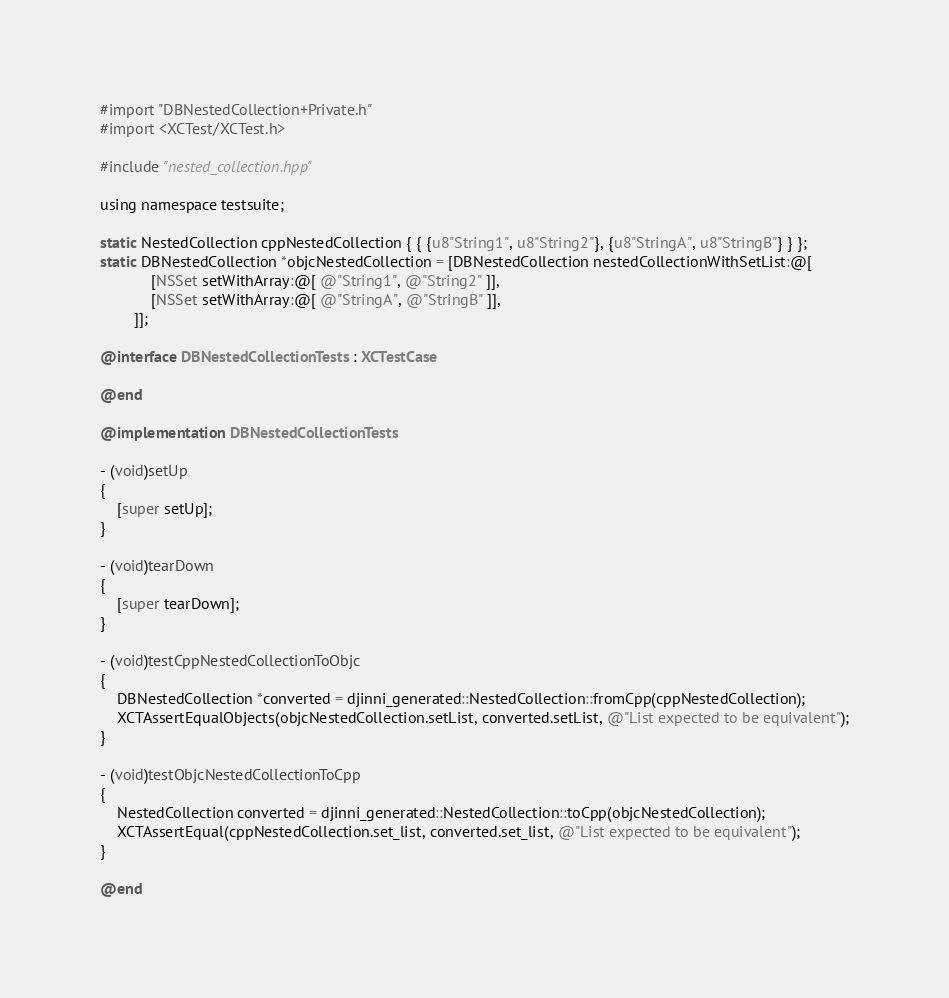<code> <loc_0><loc_0><loc_500><loc_500><_ObjectiveC_>#import "DBNestedCollection+Private.h"
#import <XCTest/XCTest.h>

#include "nested_collection.hpp"

using namespace testsuite;

static NestedCollection cppNestedCollection { { {u8"String1", u8"String2"}, {u8"StringA", u8"StringB"} } };
static DBNestedCollection *objcNestedCollection = [DBNestedCollection nestedCollectionWithSetList:@[
            [NSSet setWithArray:@[ @"String1", @"String2" ]],
            [NSSet setWithArray:@[ @"StringA", @"StringB" ]],
        ]];

@interface DBNestedCollectionTests : XCTestCase

@end

@implementation DBNestedCollectionTests

- (void)setUp
{
    [super setUp];
}

- (void)tearDown
{
    [super tearDown];
}

- (void)testCppNestedCollectionToObjc
{
    DBNestedCollection *converted = djinni_generated::NestedCollection::fromCpp(cppNestedCollection);
    XCTAssertEqualObjects(objcNestedCollection.setList, converted.setList, @"List expected to be equivalent");
}

- (void)testObjcNestedCollectionToCpp
{
    NestedCollection converted = djinni_generated::NestedCollection::toCpp(objcNestedCollection);
    XCTAssertEqual(cppNestedCollection.set_list, converted.set_list, @"List expected to be equivalent");
}

@end
</code> 